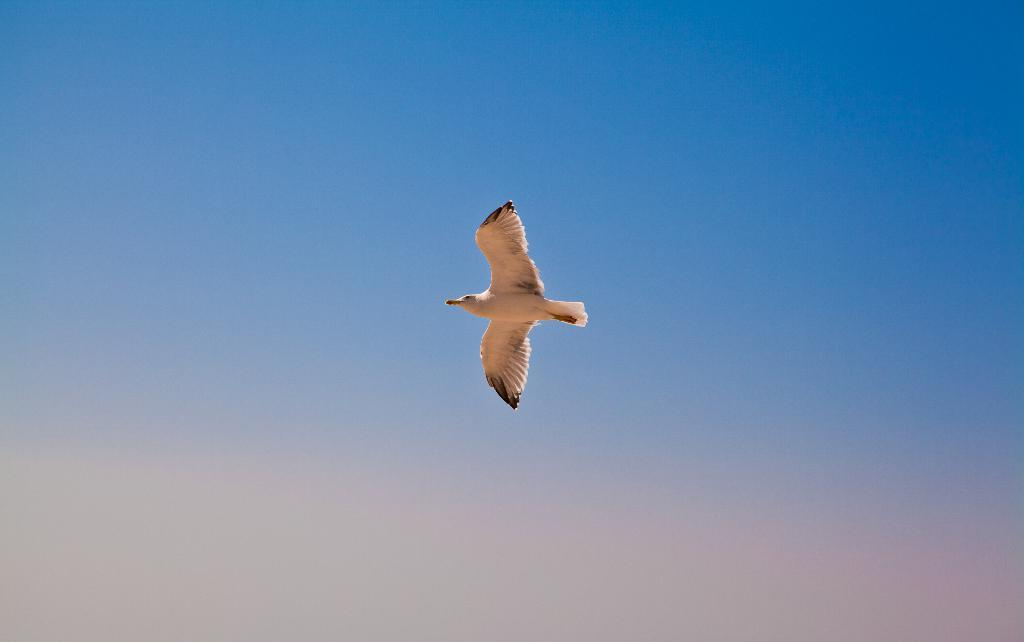What type of animal can be seen in the image? There is a bird in the image. What is the bird doing in the image? The bird is flying in the air. What can be seen in the background of the image? The sky is visible in the background of the image. What type of organization is the bird representing in the image? There is no organization represented in the image; it simply shows a bird flying in the air. 